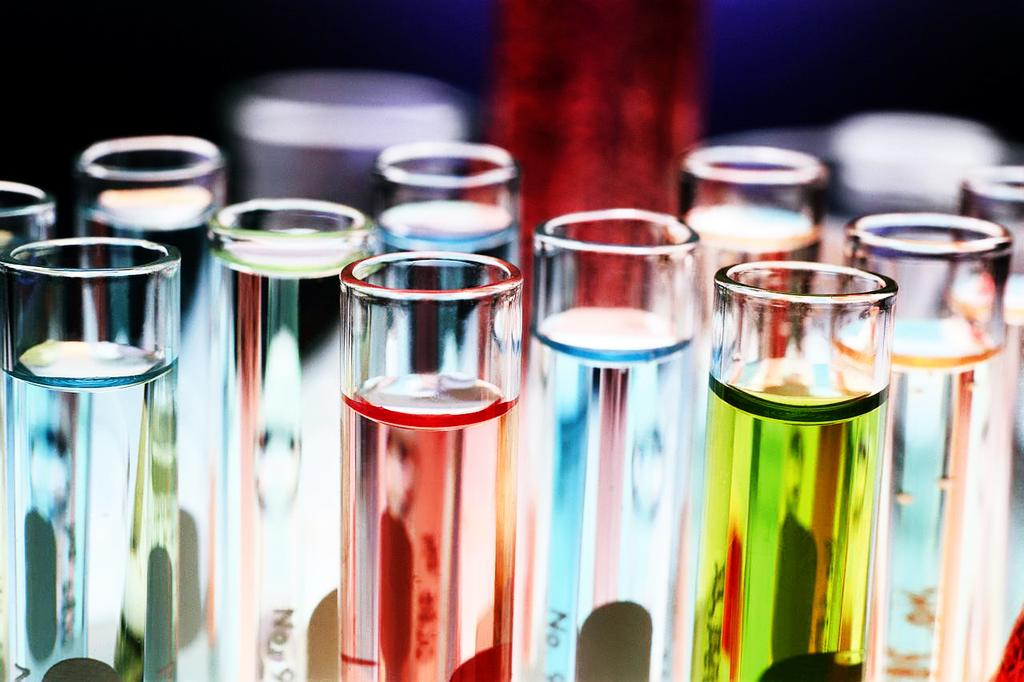<image>
Write a terse but informative summary of the picture. Man tiny tubes with one that says "No" on it. 